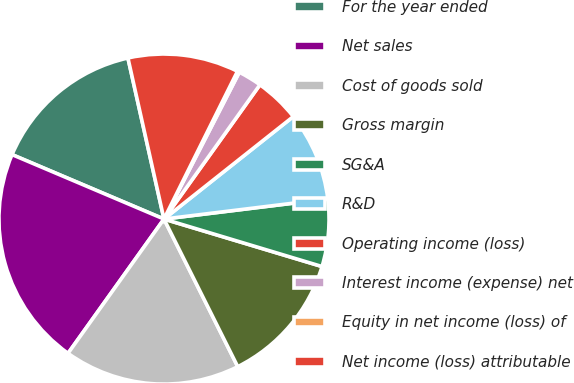Convert chart to OTSL. <chart><loc_0><loc_0><loc_500><loc_500><pie_chart><fcel>For the year ended<fcel>Net sales<fcel>Cost of goods sold<fcel>Gross margin<fcel>SG&A<fcel>R&D<fcel>Operating income (loss)<fcel>Interest income (expense) net<fcel>Equity in net income (loss) of<fcel>Net income (loss) attributable<nl><fcel>15.11%<fcel>21.51%<fcel>17.25%<fcel>12.98%<fcel>6.59%<fcel>8.72%<fcel>4.46%<fcel>2.33%<fcel>0.2%<fcel>10.85%<nl></chart> 